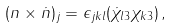<formula> <loc_0><loc_0><loc_500><loc_500>( n \times \dot { n } ) _ { j } = \epsilon _ { j k l } ( \dot { \chi } _ { l 3 } \chi _ { k 3 } ) \, ,</formula> 